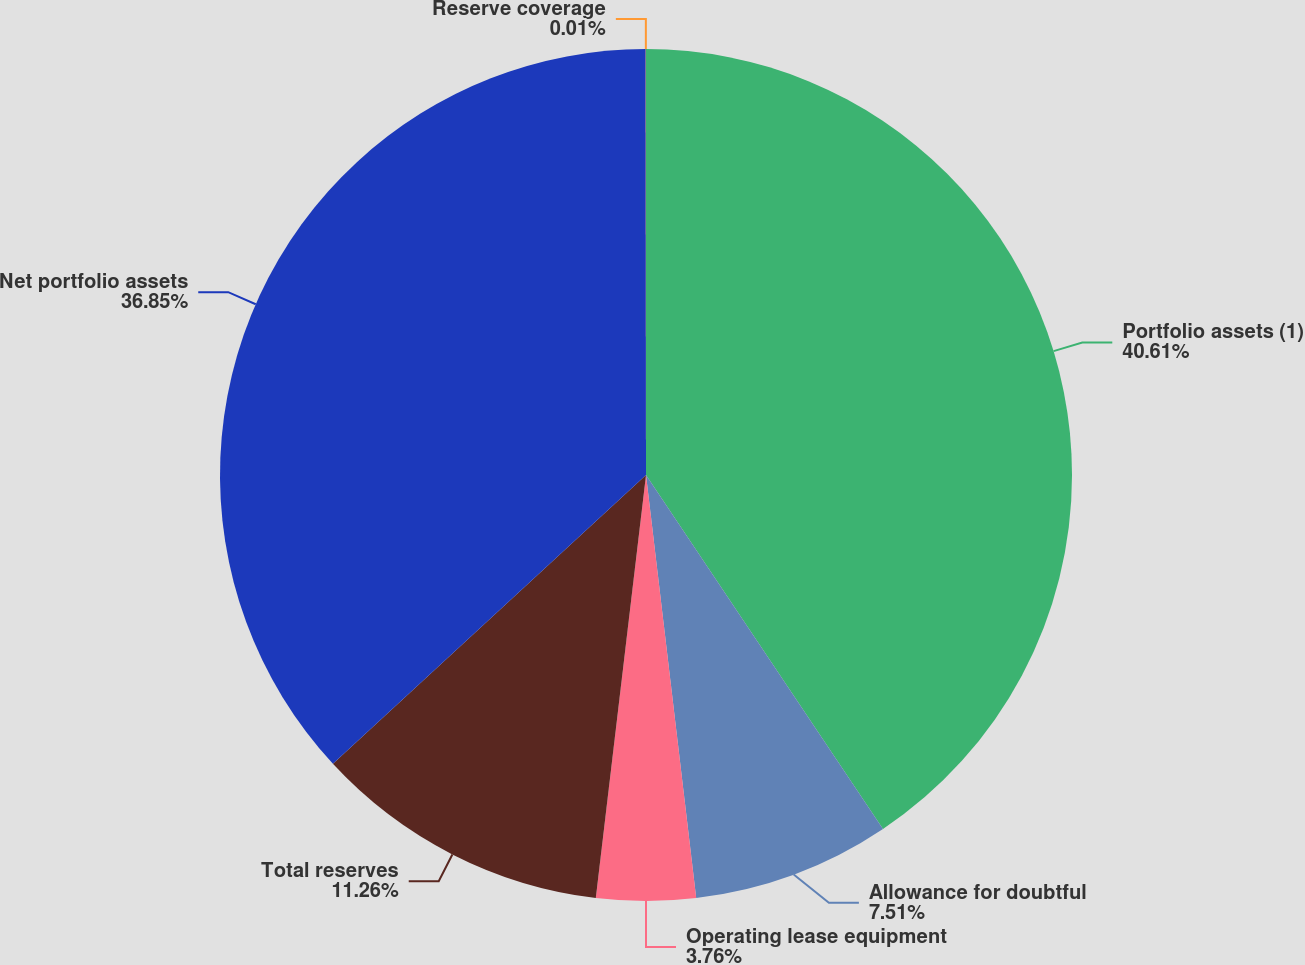<chart> <loc_0><loc_0><loc_500><loc_500><pie_chart><fcel>Portfolio assets (1)<fcel>Allowance for doubtful<fcel>Operating lease equipment<fcel>Total reserves<fcel>Net portfolio assets<fcel>Reserve coverage<nl><fcel>40.61%<fcel>7.51%<fcel>3.76%<fcel>11.26%<fcel>36.85%<fcel>0.01%<nl></chart> 